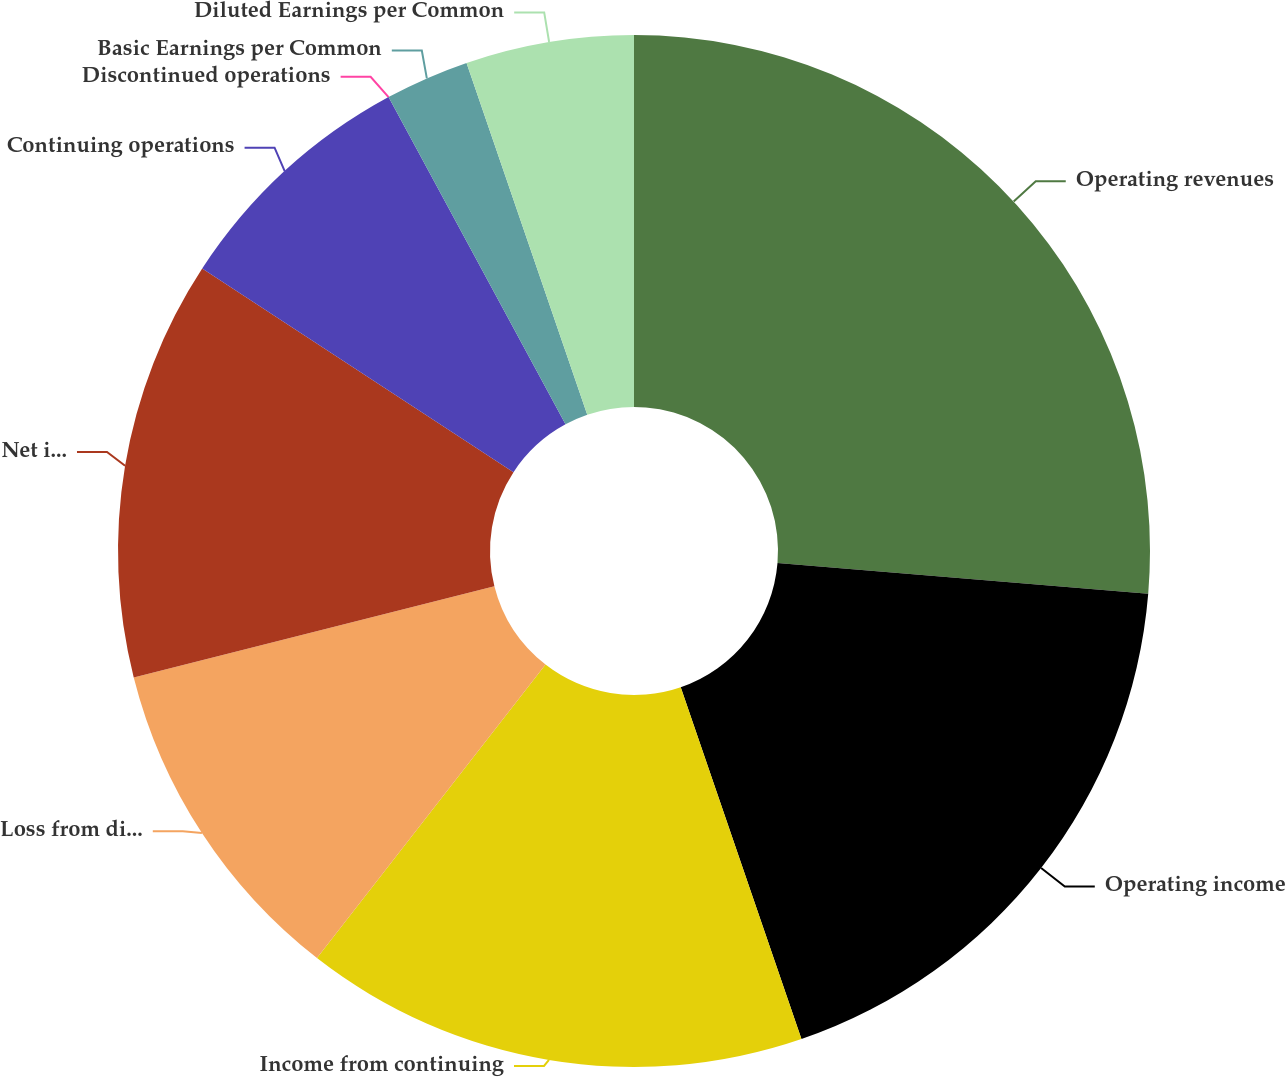Convert chart to OTSL. <chart><loc_0><loc_0><loc_500><loc_500><pie_chart><fcel>Operating revenues<fcel>Operating income<fcel>Income from continuing<fcel>Loss from discontinued<fcel>Net income<fcel>Continuing operations<fcel>Discontinued operations<fcel>Basic Earnings per Common<fcel>Diluted Earnings per Common<nl><fcel>26.32%<fcel>18.42%<fcel>15.79%<fcel>10.53%<fcel>13.16%<fcel>7.89%<fcel>0.0%<fcel>2.63%<fcel>5.26%<nl></chart> 